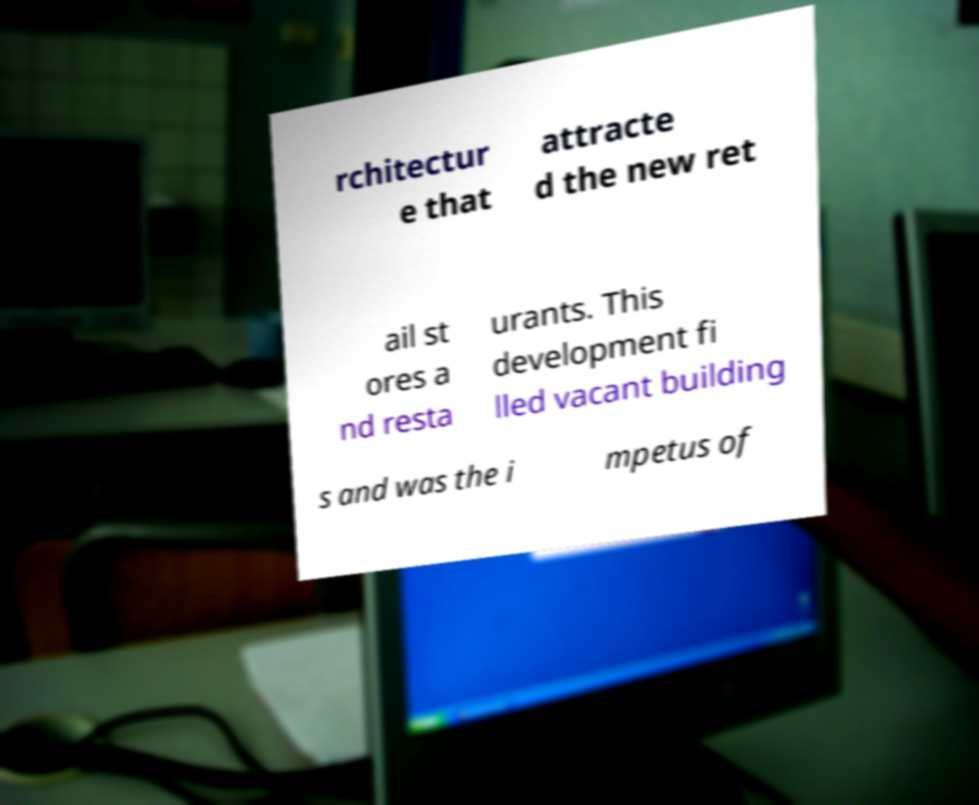What messages or text are displayed in this image? I need them in a readable, typed format. rchitectur e that attracte d the new ret ail st ores a nd resta urants. This development fi lled vacant building s and was the i mpetus of 